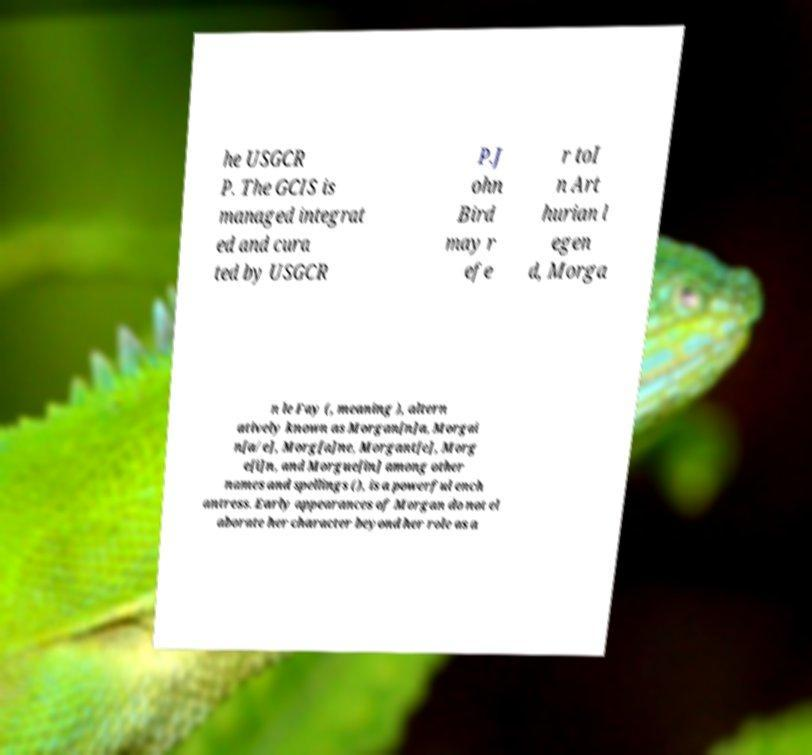There's text embedded in this image that I need extracted. Can you transcribe it verbatim? he USGCR P. The GCIS is managed integrat ed and cura ted by USGCR P.J ohn Bird may r efe r toI n Art hurian l egen d, Morga n le Fay (, meaning ), altern atively known as Morgan[n]a, Morgai n[a/e], Morg[a]ne, Morgant[e], Morg e[i]n, and Morgue[in] among other names and spellings (), is a powerful ench antress. Early appearances of Morgan do not el aborate her character beyond her role as a 